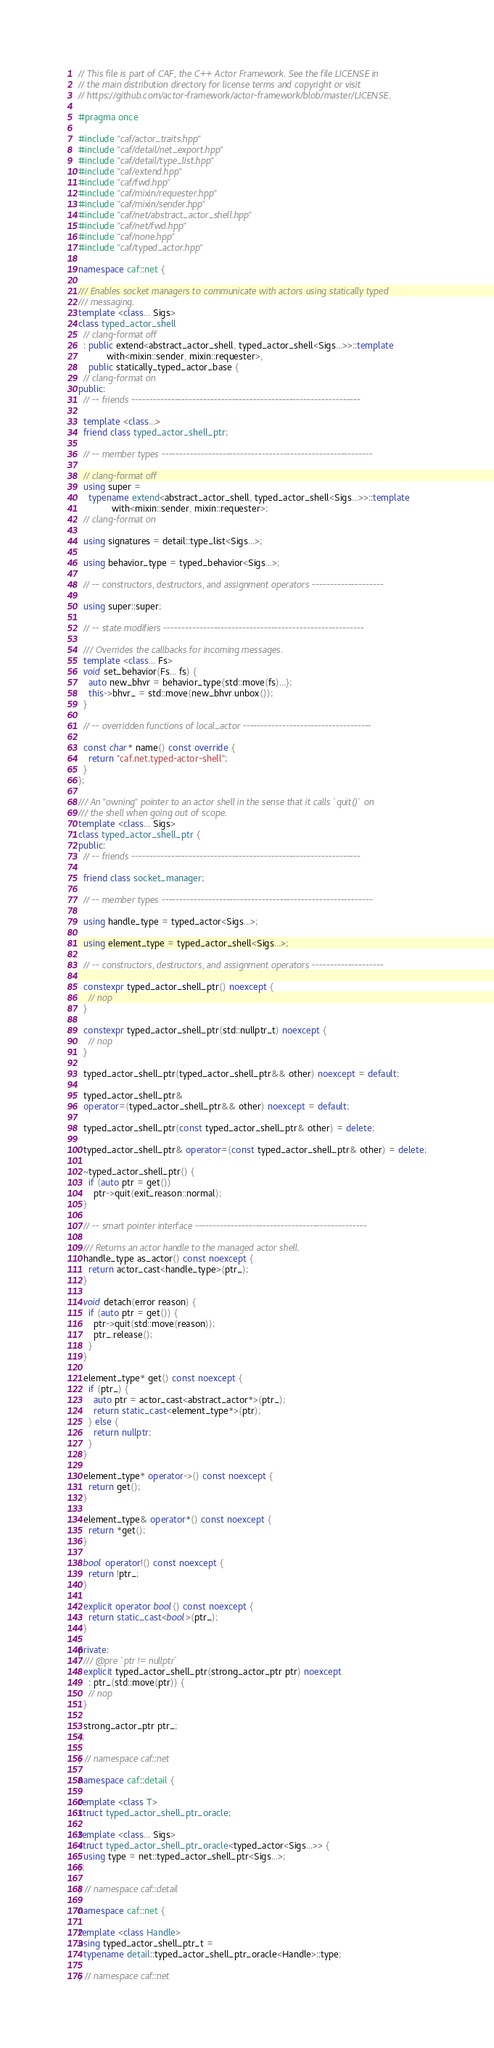<code> <loc_0><loc_0><loc_500><loc_500><_C++_>// This file is part of CAF, the C++ Actor Framework. See the file LICENSE in
// the main distribution directory for license terms and copyright or visit
// https://github.com/actor-framework/actor-framework/blob/master/LICENSE.

#pragma once

#include "caf/actor_traits.hpp"
#include "caf/detail/net_export.hpp"
#include "caf/detail/type_list.hpp"
#include "caf/extend.hpp"
#include "caf/fwd.hpp"
#include "caf/mixin/requester.hpp"
#include "caf/mixin/sender.hpp"
#include "caf/net/abstract_actor_shell.hpp"
#include "caf/net/fwd.hpp"
#include "caf/none.hpp"
#include "caf/typed_actor.hpp"

namespace caf::net {

/// Enables socket managers to communicate with actors using statically typed
/// messaging.
template <class... Sigs>
class typed_actor_shell
  // clang-format off
  : public extend<abstract_actor_shell, typed_actor_shell<Sigs...>>::template
           with<mixin::sender, mixin::requester>,
    public statically_typed_actor_base {
  // clang-format on
public:
  // -- friends ----------------------------------------------------------------

  template <class...>
  friend class typed_actor_shell_ptr;

  // -- member types -----------------------------------------------------------

  // clang-format off
  using super =
    typename extend<abstract_actor_shell, typed_actor_shell<Sigs...>>::template
             with<mixin::sender, mixin::requester>;
  // clang-format on

  using signatures = detail::type_list<Sigs...>;

  using behavior_type = typed_behavior<Sigs...>;

  // -- constructors, destructors, and assignment operators --------------------

  using super::super;

  // -- state modifiers --------------------------------------------------------

  /// Overrides the callbacks for incoming messages.
  template <class... Fs>
  void set_behavior(Fs... fs) {
    auto new_bhvr = behavior_type{std::move(fs)...};
    this->bhvr_ = std::move(new_bhvr.unbox());
  }

  // -- overridden functions of local_actor ------------------------------------

  const char* name() const override {
    return "caf.net.typed-actor-shell";
  }
};

/// An "owning" pointer to an actor shell in the sense that it calls `quit()` on
/// the shell when going out of scope.
template <class... Sigs>
class typed_actor_shell_ptr {
public:
  // -- friends ----------------------------------------------------------------

  friend class socket_manager;

  // -- member types -----------------------------------------------------------

  using handle_type = typed_actor<Sigs...>;

  using element_type = typed_actor_shell<Sigs...>;

  // -- constructors, destructors, and assignment operators --------------------

  constexpr typed_actor_shell_ptr() noexcept {
    // nop
  }

  constexpr typed_actor_shell_ptr(std::nullptr_t) noexcept {
    // nop
  }

  typed_actor_shell_ptr(typed_actor_shell_ptr&& other) noexcept = default;

  typed_actor_shell_ptr&
  operator=(typed_actor_shell_ptr&& other) noexcept = default;

  typed_actor_shell_ptr(const typed_actor_shell_ptr& other) = delete;

  typed_actor_shell_ptr& operator=(const typed_actor_shell_ptr& other) = delete;

  ~typed_actor_shell_ptr() {
    if (auto ptr = get())
      ptr->quit(exit_reason::normal);
  }

  // -- smart pointer interface ------------------------------------------------

  /// Returns an actor handle to the managed actor shell.
  handle_type as_actor() const noexcept {
    return actor_cast<handle_type>(ptr_);
  }

  void detach(error reason) {
    if (auto ptr = get()) {
      ptr->quit(std::move(reason));
      ptr_.release();
    }
  }

  element_type* get() const noexcept {
    if (ptr_) {
      auto ptr = actor_cast<abstract_actor*>(ptr_);
      return static_cast<element_type*>(ptr);
    } else {
      return nullptr;
    }
  }

  element_type* operator->() const noexcept {
    return get();
  }

  element_type& operator*() const noexcept {
    return *get();
  }

  bool operator!() const noexcept {
    return !ptr_;
  }

  explicit operator bool() const noexcept {
    return static_cast<bool>(ptr_);
  }

private:
  /// @pre `ptr != nullptr`
  explicit typed_actor_shell_ptr(strong_actor_ptr ptr) noexcept
    : ptr_(std::move(ptr)) {
    // nop
  }

  strong_actor_ptr ptr_;
};

} // namespace caf::net

namespace caf::detail {

template <class T>
struct typed_actor_shell_ptr_oracle;

template <class... Sigs>
struct typed_actor_shell_ptr_oracle<typed_actor<Sigs...>> {
  using type = net::typed_actor_shell_ptr<Sigs...>;
};

} // namespace caf::detail

namespace caf::net {

template <class Handle>
using typed_actor_shell_ptr_t =
  typename detail::typed_actor_shell_ptr_oracle<Handle>::type;

} // namespace caf::net
</code> 